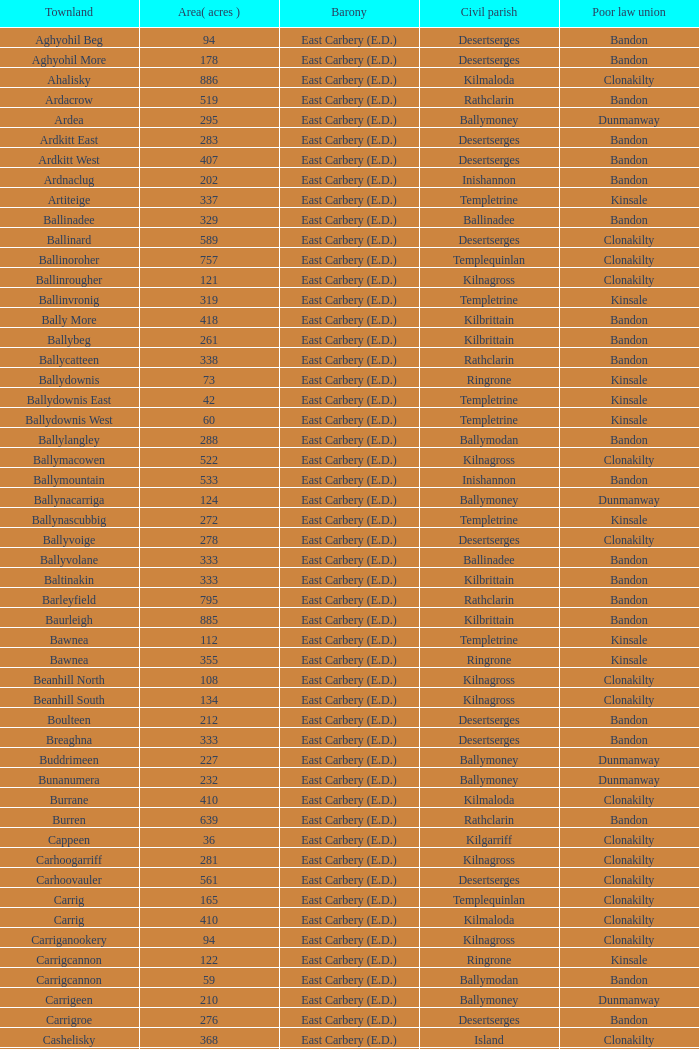What is the poor law union of the Lackenagobidane townland? Clonakilty. 